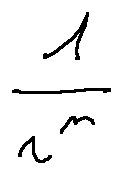Convert formula to latex. <formula><loc_0><loc_0><loc_500><loc_500>\frac { 1 } { r ^ { n } }</formula> 